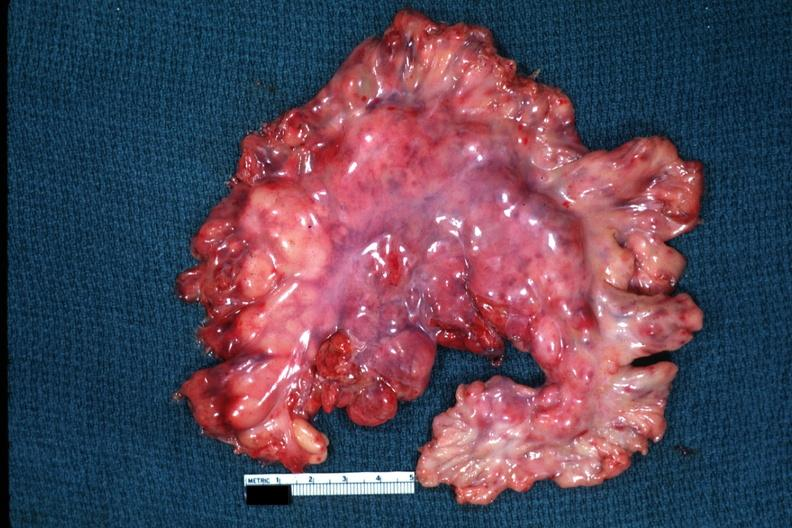what does this image show?
Answer the question using a single word or phrase. Massive node enlargement like a lymphoma 